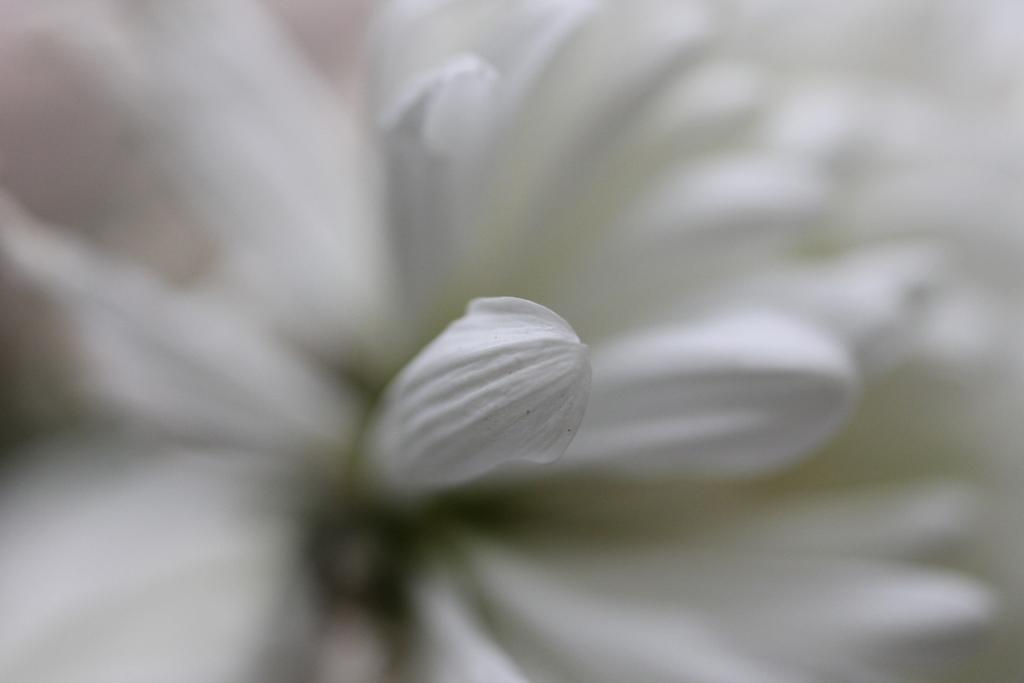What is the main subject of the image? There is a flower in the image. Can you describe the background of the image? The background of the image is blurry. What type of cork can be seen in the image? There is no cork present in the image; it features a flower and a blurry background. What book is the person reading in the image? There is no person or book present in the image; it only features a flower and a blurry background. 